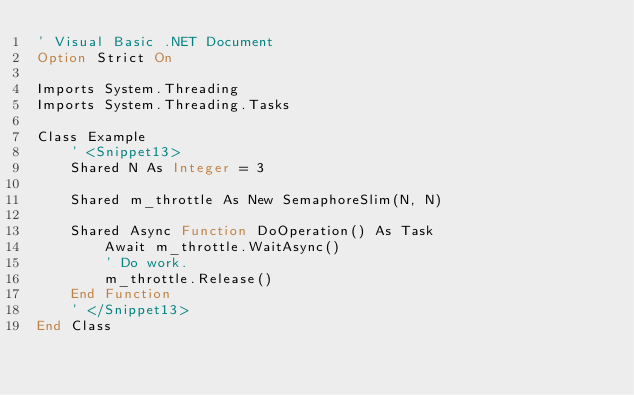Convert code to text. <code><loc_0><loc_0><loc_500><loc_500><_VisualBasic_>' Visual Basic .NET Document
Option Strict On

Imports System.Threading
Imports System.Threading.Tasks

Class Example
    ' <Snippet13>
    Shared N As Integer = 3
    
    Shared m_throttle As New SemaphoreSlim(N, N)
    
    Shared Async Function DoOperation() As Task
        Await m_throttle.WaitAsync()
        ' Do work.
        m_throttle.Release()
    End Function
    ' </Snippet13>
End Class

</code> 